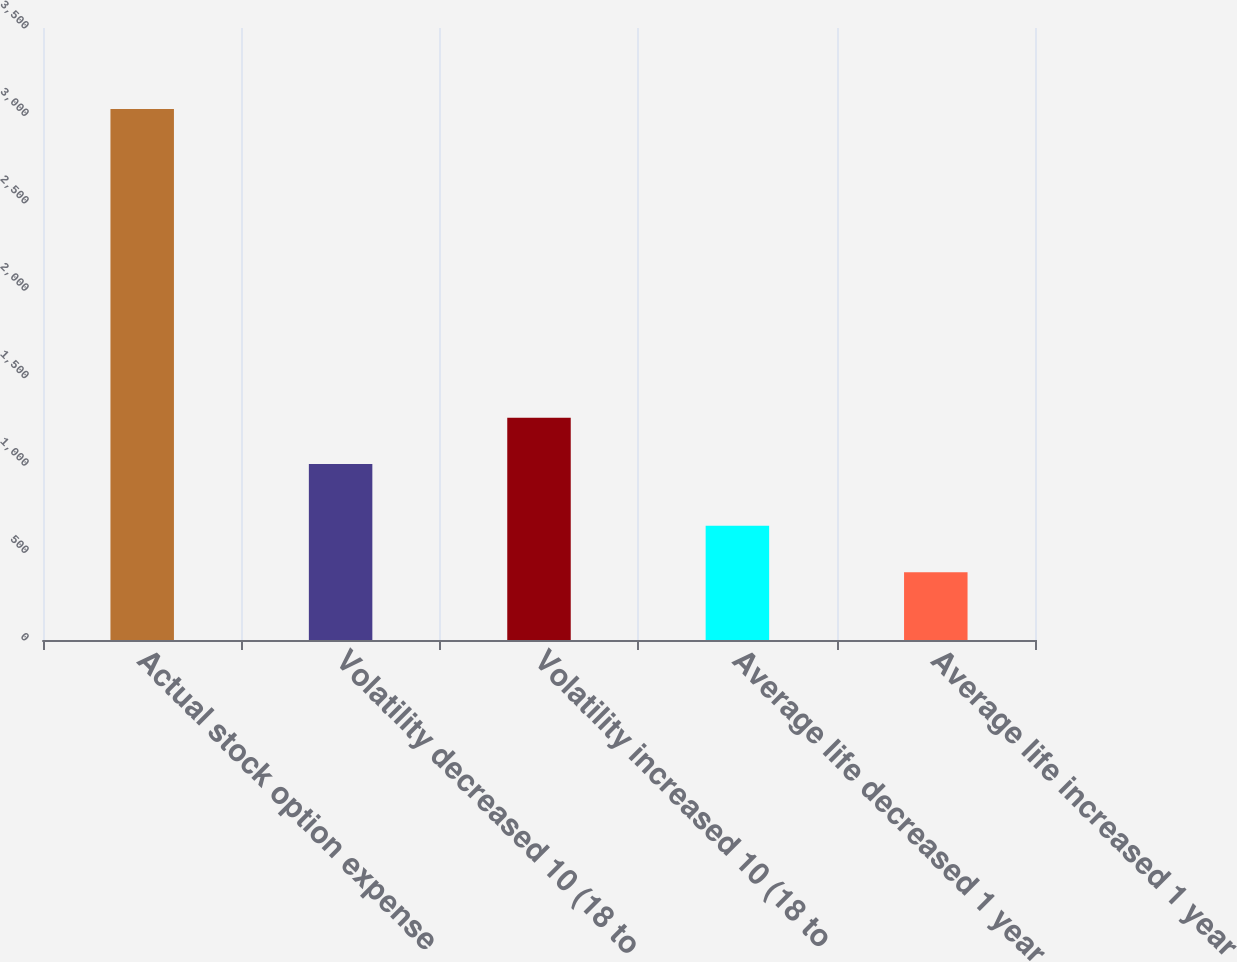Convert chart to OTSL. <chart><loc_0><loc_0><loc_500><loc_500><bar_chart><fcel>Actual stock option expense<fcel>Volatility decreased 10 (18 to<fcel>Volatility increased 10 (18 to<fcel>Average life decreased 1 year<fcel>Average life increased 1 year<nl><fcel>3037<fcel>1006<fcel>1270.9<fcel>652.9<fcel>388<nl></chart> 